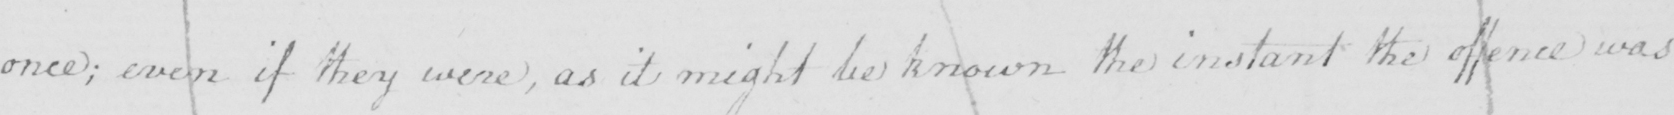Can you read and transcribe this handwriting? once ; even if they were , as it might be known the instant the offence was 